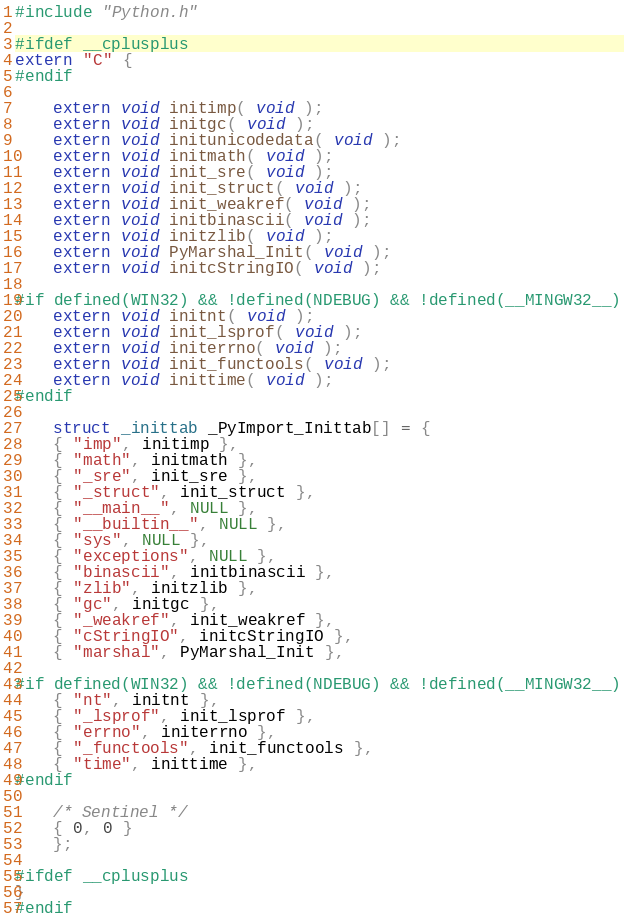<code> <loc_0><loc_0><loc_500><loc_500><_C_>#include "Python.h"

#ifdef __cplusplus
extern "C" {
#endif

    extern void initimp( void );
    extern void initgc( void );
    extern void initunicodedata( void );
    extern void initmath( void );
    extern void init_sre( void );
    extern void init_struct( void );
    extern void init_weakref( void );
    extern void initbinascii( void );
    extern void initzlib( void );
    extern void PyMarshal_Init( void );
    extern void initcStringIO( void );

#if defined(WIN32) && !defined(NDEBUG) && !defined(__MINGW32__)
    extern void initnt( void );
    extern void init_lsprof( void );
    extern void initerrno( void );    
    extern void init_functools( void );
    extern void inittime( void );
#endif

    struct _inittab _PyImport_Inittab[] = {
    { "imp", initimp },
    { "math", initmath },
    { "_sre", init_sre },
    { "_struct", init_struct },
    { "__main__", NULL },
    { "__builtin__", NULL },
    { "sys", NULL },
    { "exceptions", NULL },
    { "binascii", initbinascii },
    { "zlib", initzlib },
    { "gc", initgc },
    { "_weakref", init_weakref },
    { "cStringIO", initcStringIO },
    { "marshal", PyMarshal_Init },

#if defined(WIN32) && !defined(NDEBUG) && !defined(__MINGW32__)
    { "nt", initnt },
    { "_lsprof", init_lsprof },
    { "errno", initerrno },
    { "_functools", init_functools },
    { "time", inittime },
#endif

    /* Sentinel */
    { 0, 0 }
    };

#ifdef __cplusplus
}
#endif

</code> 